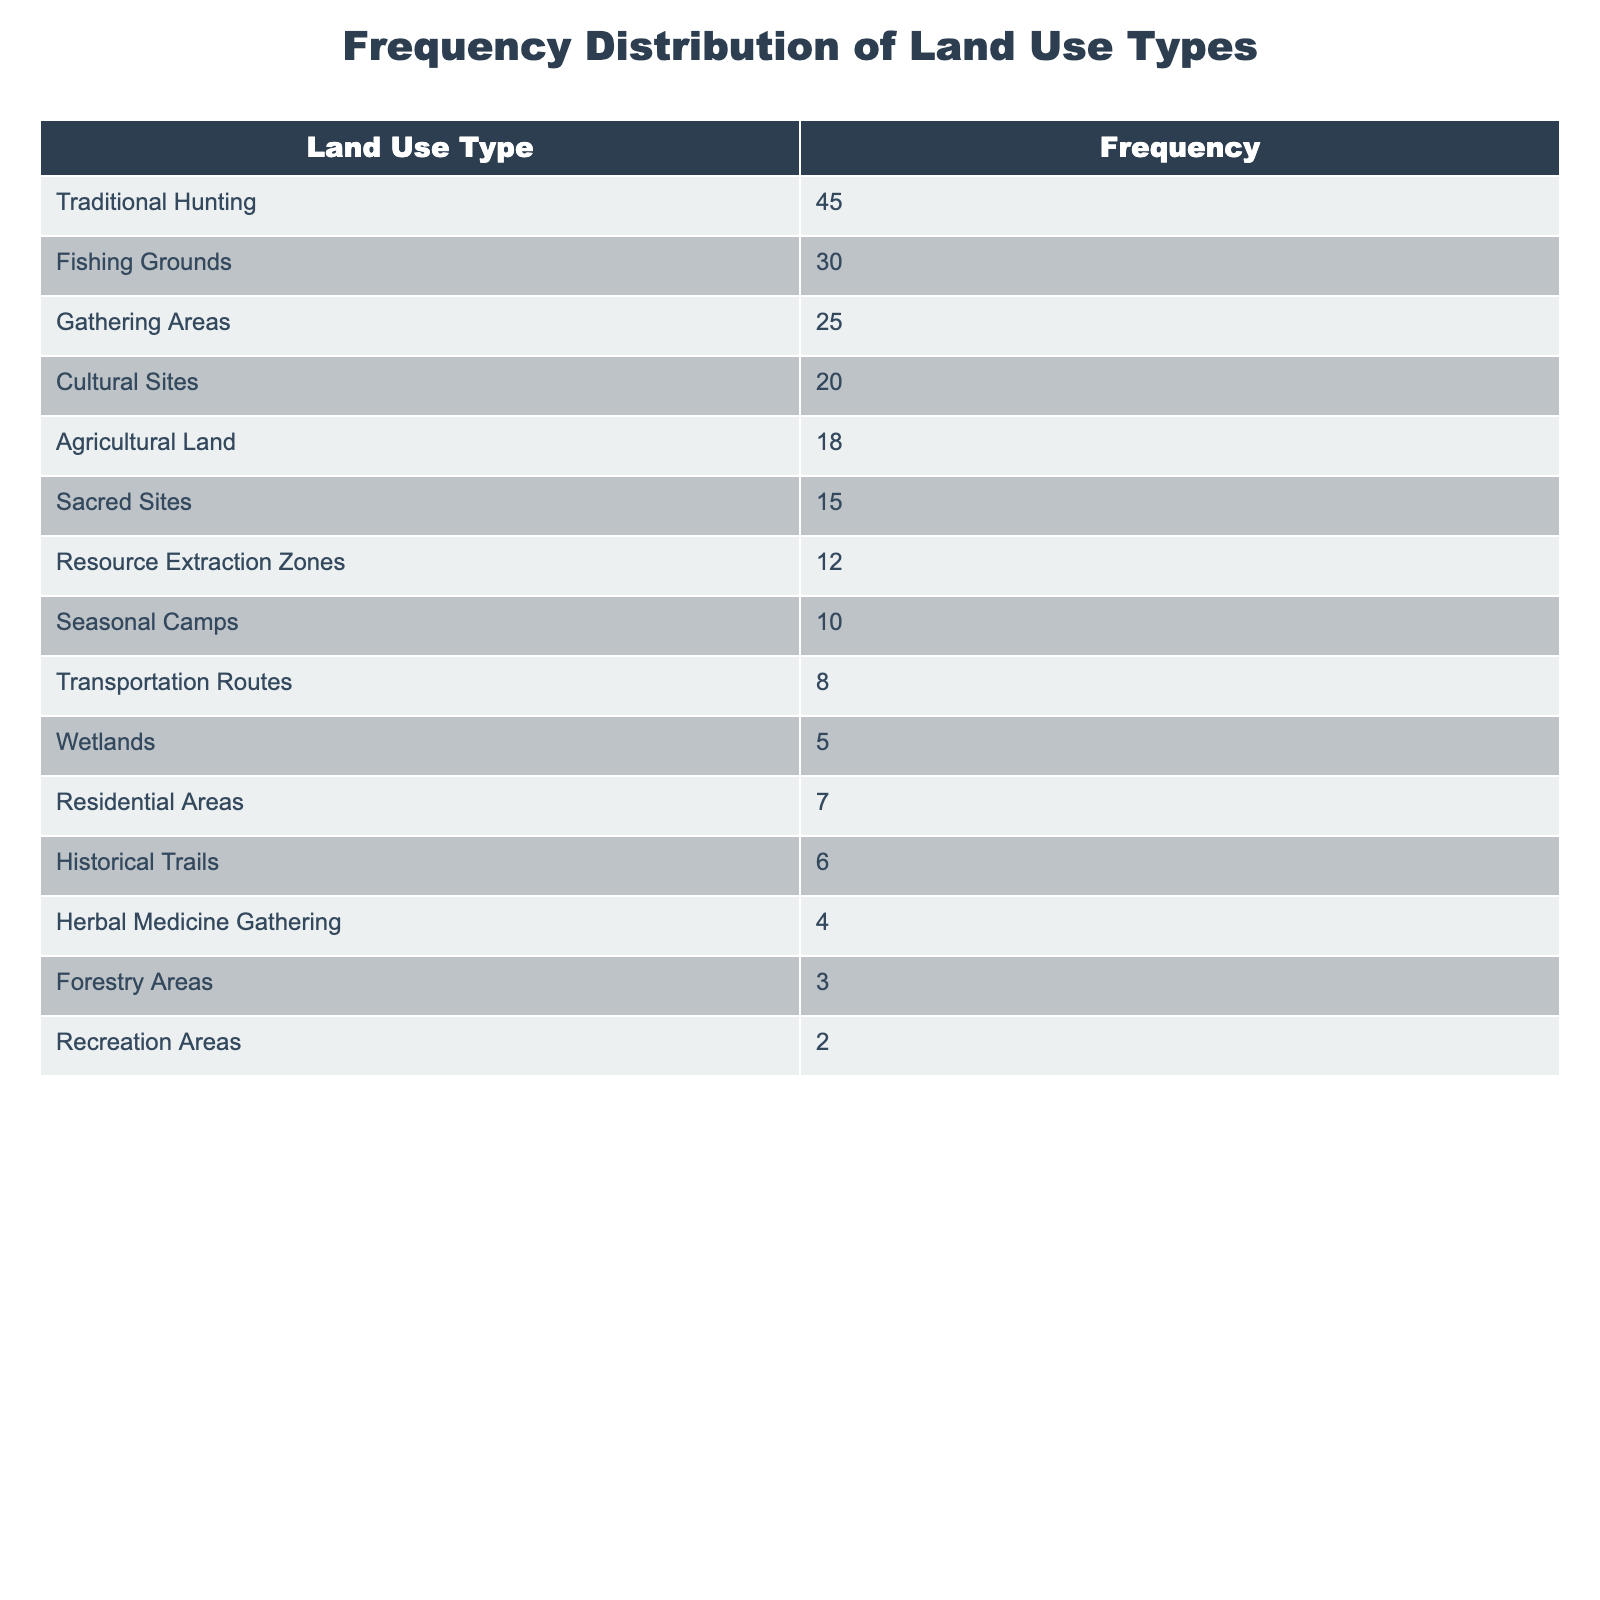What is the frequency of Traditional Hunting? The table lists Traditional Hunting with a frequency of 45.
Answer: 45 Which land use type has the highest frequency? Traditional Hunting has the highest frequency, listed at 45 in the table.
Answer: Traditional Hunting What is the total frequency of Cultural Sites and Agricultural Land combined? The frequency of Cultural Sites is 20 and Agricultural Land is 18. Adding these together: 20 + 18 = 38.
Answer: 38 Are there more claims related to Fishing Grounds than to Sacred Sites? Fishing Grounds has a frequency of 30, while Sacred Sites has a frequency of 15. Since 30 is greater than 15, the statement is true.
Answer: Yes What is the average frequency of land use types that have a frequency higher than 10? The land use types with frequency higher than 10 are Traditional Hunting (45), Fishing Grounds (30), Gathering Areas (25), Cultural Sites (20), Agricultural Land (18), Sacred Sites (15), and Resource Extraction Zones (12). There are 7 types, and their total frequency is 45 + 30 + 25 + 20 + 18 + 15 + 12 = 175. The average is 175 divided by 7, which equals 25.
Answer: 25 How many land use types have a frequency less than 10? The land use types with frequency less than 10 are Seasonal Camps (10), Transportation Routes (8), Wetlands (5), Residential Areas (7), Historical Trails (6), Herbal Medicine Gathering (4), Forestry Areas (3), and Recreation Areas (2). Counting these, there are 8 types total.
Answer: 8 What is the difference in frequency between the highest and lowest land use types? The highest frequency is 45 for Traditional Hunting, and the lowest is 2 for Recreation Areas. The difference is 45 - 2 = 43.
Answer: 43 Is the frequency of Gathering Areas equal to that of Residential Areas? Gathering Areas has a frequency of 25, while Residential Areas has a frequency of 7. Since 25 is not equal to 7, the statement is false.
Answer: No Which land use type has a frequency that falls exactly in the middle of the range between the highest and lowest frequencies? The highest frequency is 45 (Traditional Hunting) and the lowest is 2 (Recreation Areas). The middle value is calculated as (45 + 2) / 2 = 23.5. The nearest land use type is Gathering Areas with a frequency of 25, as it is the closest to 23.5, which is higher.
Answer: Gathering Areas 